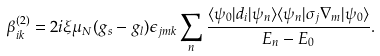Convert formula to latex. <formula><loc_0><loc_0><loc_500><loc_500>\beta _ { i k } ^ { ( 2 ) } = 2 i \xi \mu _ { N } ( g _ { s } - g _ { l } ) \epsilon _ { j m k } \sum _ { n } \frac { \langle \psi _ { 0 } | d _ { i } | \psi _ { n } \rangle \langle \psi _ { n } | \sigma _ { j } \nabla _ { m } | \psi _ { 0 } \rangle } { E _ { n } - E _ { 0 } } .</formula> 